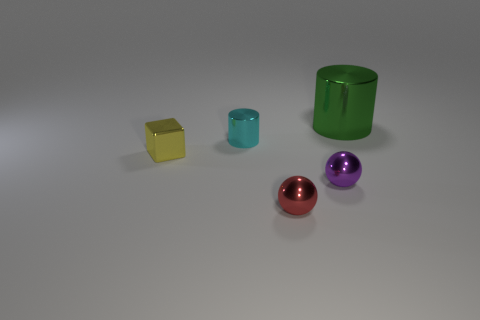Add 4 purple spheres. How many objects exist? 9 Subtract all cubes. How many objects are left? 4 Subtract 0 blue balls. How many objects are left? 5 Subtract all small purple metallic cylinders. Subtract all large green metallic cylinders. How many objects are left? 4 Add 3 green cylinders. How many green cylinders are left? 4 Add 2 big things. How many big things exist? 3 